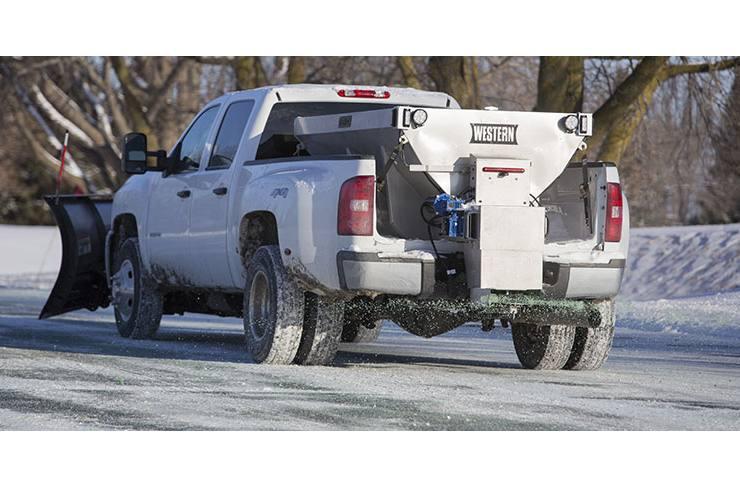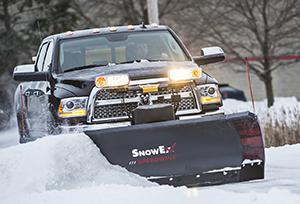The first image is the image on the left, the second image is the image on the right. Evaluate the accuracy of this statement regarding the images: "At least one truck is pushing snow.". Is it true? Answer yes or no. Yes. 